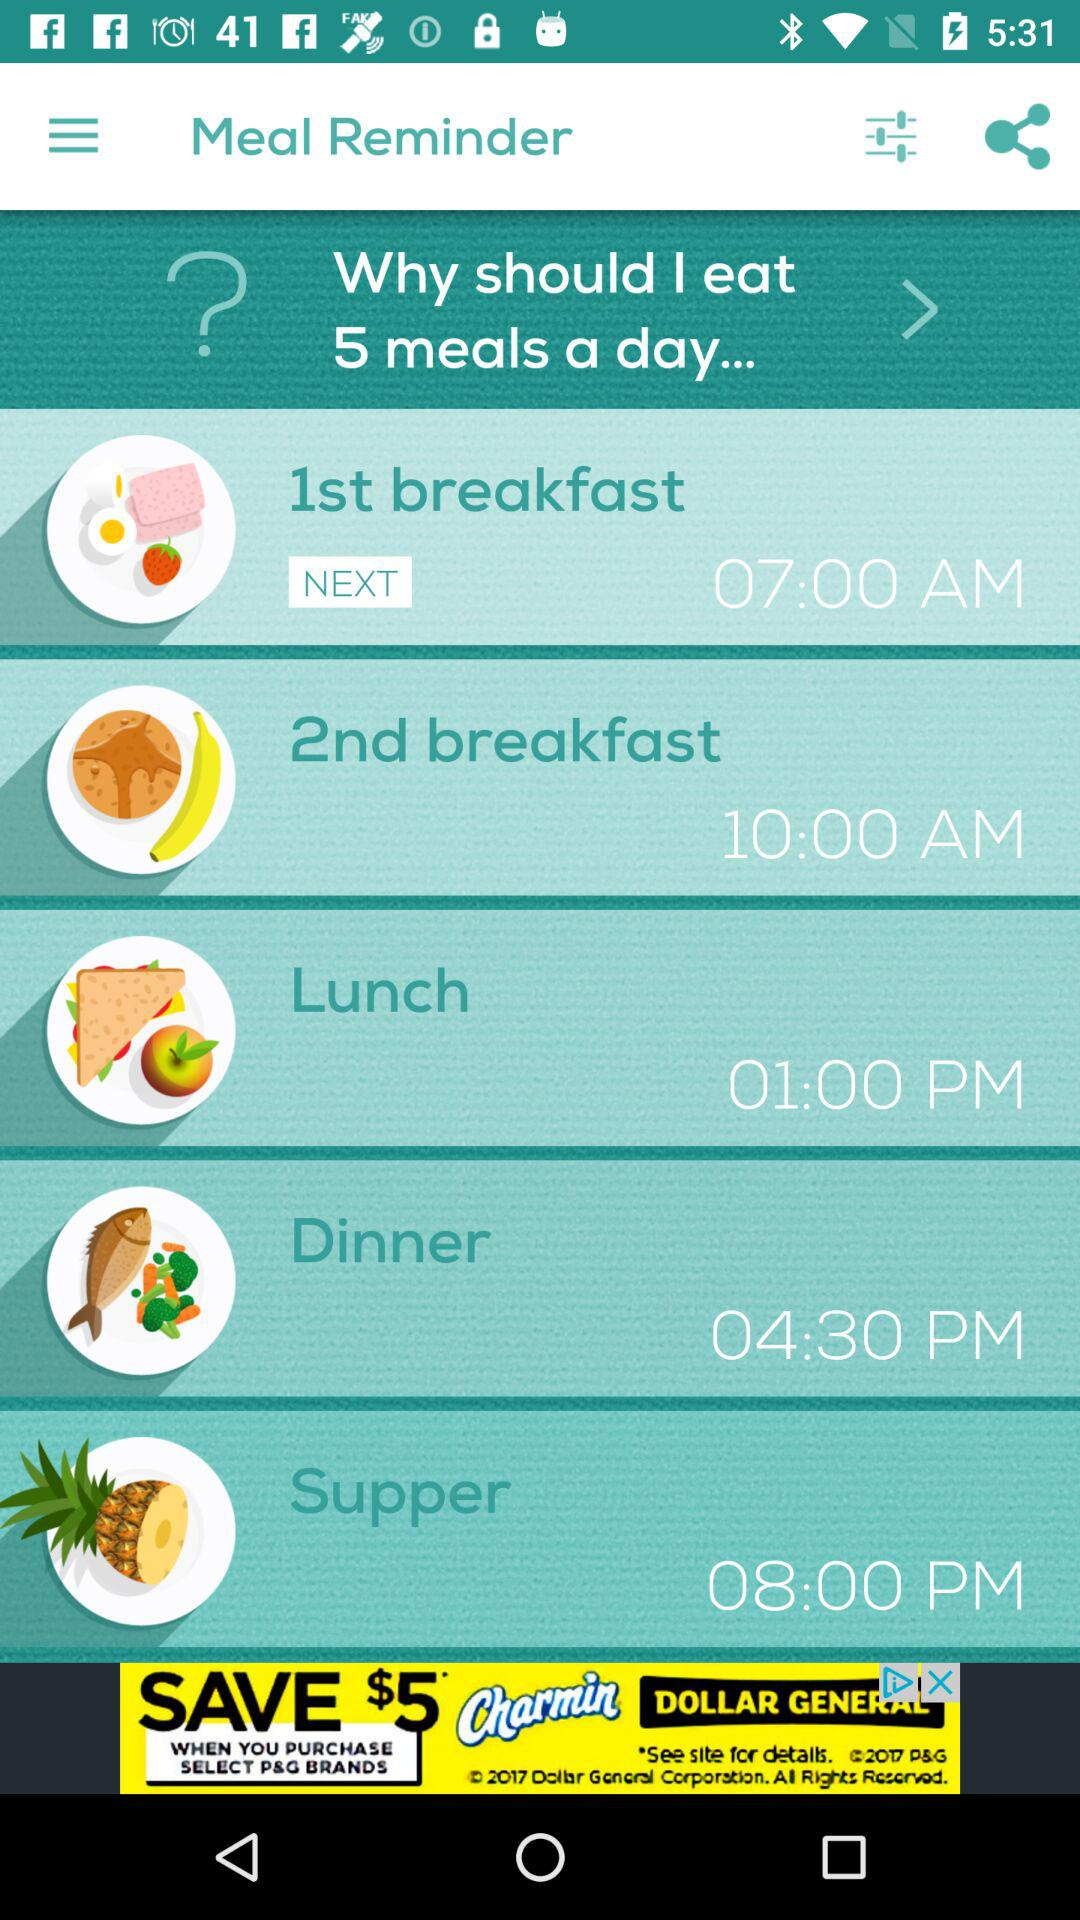What is dinner time? Dinner time is 4:30 PM. 